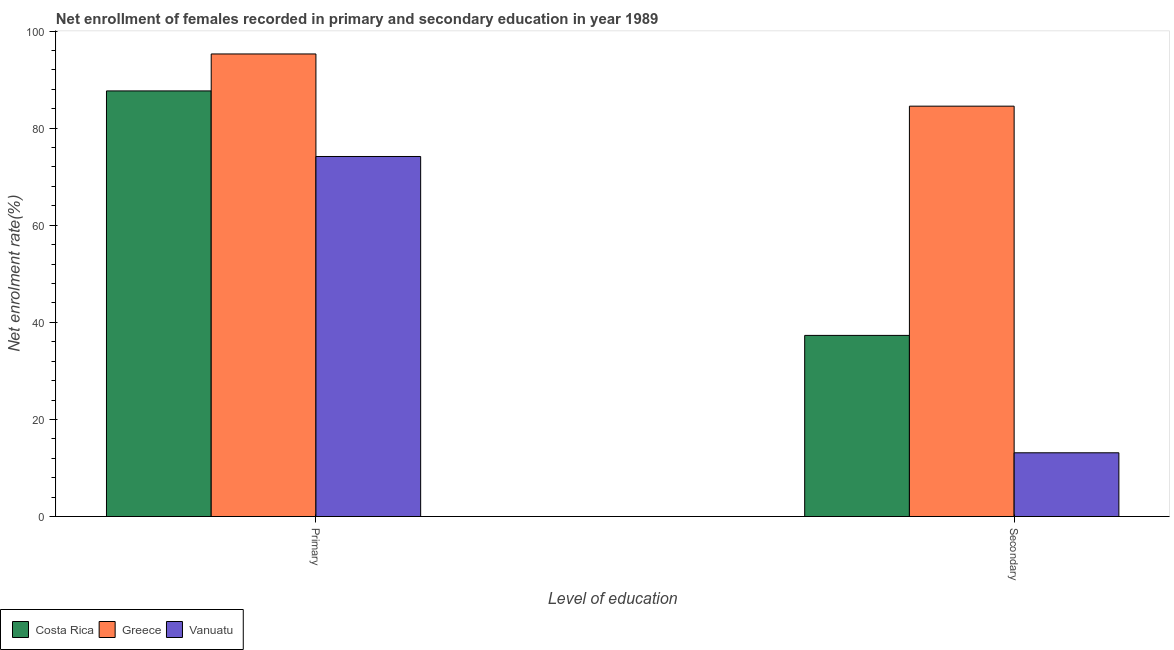How many different coloured bars are there?
Give a very brief answer. 3. How many groups of bars are there?
Make the answer very short. 2. Are the number of bars on each tick of the X-axis equal?
Your answer should be compact. Yes. How many bars are there on the 1st tick from the right?
Your response must be concise. 3. What is the label of the 2nd group of bars from the left?
Provide a succinct answer. Secondary. What is the enrollment rate in secondary education in Greece?
Your answer should be compact. 84.53. Across all countries, what is the maximum enrollment rate in primary education?
Your response must be concise. 95.28. Across all countries, what is the minimum enrollment rate in secondary education?
Keep it short and to the point. 13.13. In which country was the enrollment rate in primary education minimum?
Your response must be concise. Vanuatu. What is the total enrollment rate in secondary education in the graph?
Provide a short and direct response. 134.96. What is the difference between the enrollment rate in primary education in Greece and that in Vanuatu?
Your response must be concise. 21.12. What is the difference between the enrollment rate in secondary education in Costa Rica and the enrollment rate in primary education in Vanuatu?
Offer a terse response. -36.85. What is the average enrollment rate in primary education per country?
Offer a very short reply. 85.7. What is the difference between the enrollment rate in secondary education and enrollment rate in primary education in Costa Rica?
Offer a very short reply. -50.36. In how many countries, is the enrollment rate in secondary education greater than 92 %?
Your answer should be very brief. 0. What is the ratio of the enrollment rate in primary education in Costa Rica to that in Greece?
Offer a terse response. 0.92. Is the enrollment rate in secondary education in Costa Rica less than that in Greece?
Provide a short and direct response. Yes. What does the 1st bar from the left in Primary represents?
Offer a very short reply. Costa Rica. What does the 1st bar from the right in Primary represents?
Give a very brief answer. Vanuatu. Are all the bars in the graph horizontal?
Make the answer very short. No. What is the difference between two consecutive major ticks on the Y-axis?
Offer a terse response. 20. Are the values on the major ticks of Y-axis written in scientific E-notation?
Offer a very short reply. No. Does the graph contain grids?
Provide a succinct answer. No. How many legend labels are there?
Give a very brief answer. 3. What is the title of the graph?
Give a very brief answer. Net enrollment of females recorded in primary and secondary education in year 1989. Does "Madagascar" appear as one of the legend labels in the graph?
Offer a terse response. No. What is the label or title of the X-axis?
Provide a succinct answer. Level of education. What is the label or title of the Y-axis?
Ensure brevity in your answer.  Net enrolment rate(%). What is the Net enrolment rate(%) in Costa Rica in Primary?
Give a very brief answer. 87.67. What is the Net enrolment rate(%) of Greece in Primary?
Your answer should be compact. 95.28. What is the Net enrolment rate(%) in Vanuatu in Primary?
Make the answer very short. 74.16. What is the Net enrolment rate(%) of Costa Rica in Secondary?
Offer a very short reply. 37.31. What is the Net enrolment rate(%) in Greece in Secondary?
Keep it short and to the point. 84.53. What is the Net enrolment rate(%) of Vanuatu in Secondary?
Provide a short and direct response. 13.13. Across all Level of education, what is the maximum Net enrolment rate(%) of Costa Rica?
Provide a short and direct response. 87.67. Across all Level of education, what is the maximum Net enrolment rate(%) in Greece?
Provide a succinct answer. 95.28. Across all Level of education, what is the maximum Net enrolment rate(%) of Vanuatu?
Make the answer very short. 74.16. Across all Level of education, what is the minimum Net enrolment rate(%) of Costa Rica?
Your answer should be very brief. 37.31. Across all Level of education, what is the minimum Net enrolment rate(%) in Greece?
Provide a short and direct response. 84.53. Across all Level of education, what is the minimum Net enrolment rate(%) in Vanuatu?
Provide a succinct answer. 13.13. What is the total Net enrolment rate(%) in Costa Rica in the graph?
Your answer should be very brief. 124.97. What is the total Net enrolment rate(%) of Greece in the graph?
Provide a short and direct response. 179.81. What is the total Net enrolment rate(%) in Vanuatu in the graph?
Offer a terse response. 87.29. What is the difference between the Net enrolment rate(%) in Costa Rica in Primary and that in Secondary?
Offer a terse response. 50.36. What is the difference between the Net enrolment rate(%) of Greece in Primary and that in Secondary?
Provide a short and direct response. 10.76. What is the difference between the Net enrolment rate(%) in Vanuatu in Primary and that in Secondary?
Your answer should be compact. 61.03. What is the difference between the Net enrolment rate(%) in Costa Rica in Primary and the Net enrolment rate(%) in Greece in Secondary?
Your answer should be very brief. 3.14. What is the difference between the Net enrolment rate(%) in Costa Rica in Primary and the Net enrolment rate(%) in Vanuatu in Secondary?
Your response must be concise. 74.54. What is the difference between the Net enrolment rate(%) in Greece in Primary and the Net enrolment rate(%) in Vanuatu in Secondary?
Give a very brief answer. 82.15. What is the average Net enrolment rate(%) in Costa Rica per Level of education?
Provide a succinct answer. 62.49. What is the average Net enrolment rate(%) of Greece per Level of education?
Give a very brief answer. 89.9. What is the average Net enrolment rate(%) of Vanuatu per Level of education?
Give a very brief answer. 43.64. What is the difference between the Net enrolment rate(%) of Costa Rica and Net enrolment rate(%) of Greece in Primary?
Provide a short and direct response. -7.61. What is the difference between the Net enrolment rate(%) in Costa Rica and Net enrolment rate(%) in Vanuatu in Primary?
Offer a terse response. 13.51. What is the difference between the Net enrolment rate(%) in Greece and Net enrolment rate(%) in Vanuatu in Primary?
Your answer should be very brief. 21.12. What is the difference between the Net enrolment rate(%) in Costa Rica and Net enrolment rate(%) in Greece in Secondary?
Keep it short and to the point. -47.22. What is the difference between the Net enrolment rate(%) in Costa Rica and Net enrolment rate(%) in Vanuatu in Secondary?
Ensure brevity in your answer.  24.18. What is the difference between the Net enrolment rate(%) in Greece and Net enrolment rate(%) in Vanuatu in Secondary?
Ensure brevity in your answer.  71.4. What is the ratio of the Net enrolment rate(%) in Costa Rica in Primary to that in Secondary?
Make the answer very short. 2.35. What is the ratio of the Net enrolment rate(%) of Greece in Primary to that in Secondary?
Provide a succinct answer. 1.13. What is the ratio of the Net enrolment rate(%) in Vanuatu in Primary to that in Secondary?
Provide a succinct answer. 5.65. What is the difference between the highest and the second highest Net enrolment rate(%) in Costa Rica?
Ensure brevity in your answer.  50.36. What is the difference between the highest and the second highest Net enrolment rate(%) of Greece?
Offer a terse response. 10.76. What is the difference between the highest and the second highest Net enrolment rate(%) of Vanuatu?
Offer a very short reply. 61.03. What is the difference between the highest and the lowest Net enrolment rate(%) in Costa Rica?
Ensure brevity in your answer.  50.36. What is the difference between the highest and the lowest Net enrolment rate(%) in Greece?
Your response must be concise. 10.76. What is the difference between the highest and the lowest Net enrolment rate(%) in Vanuatu?
Offer a very short reply. 61.03. 